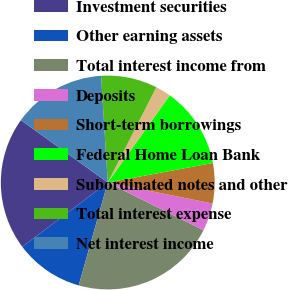Convert chart. <chart><loc_0><loc_0><loc_500><loc_500><pie_chart><fcel>Investment securities<fcel>Other earning assets<fcel>Total interest income from<fcel>Deposits<fcel>Short-term borrowings<fcel>Federal Home Loan Bank<fcel>Subordinated notes and other<fcel>Total interest expense<fcel>Net interest income<nl><fcel>20.16%<fcel>10.37%<fcel>22.02%<fcel>4.21%<fcel>6.07%<fcel>12.23%<fcel>2.34%<fcel>8.5%<fcel>14.1%<nl></chart> 